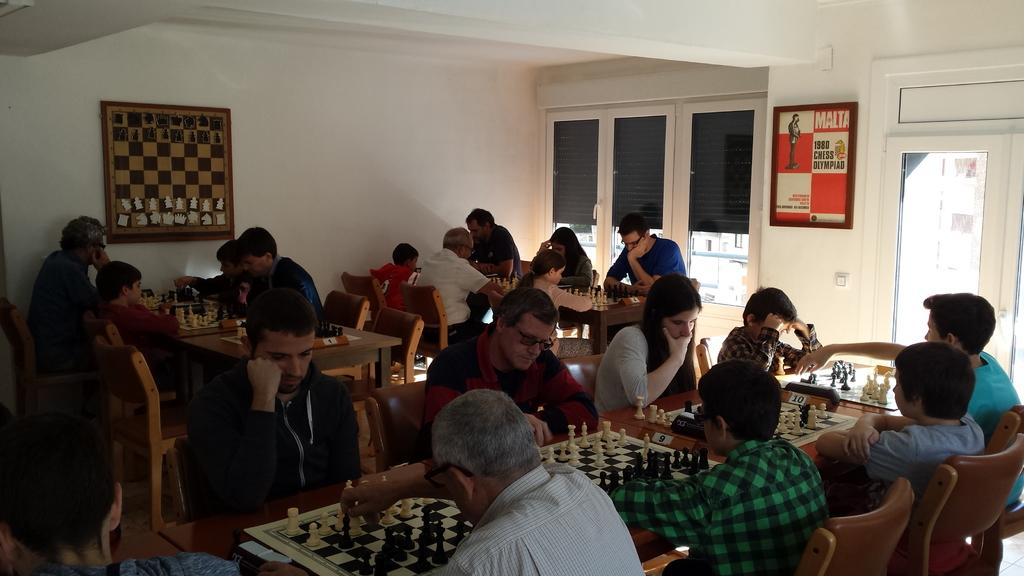What activity is taking place in the image? There is a chess competition in the image. How are the participants positioned during the competition? There are people sitting on chairs in the image. What game are the people playing? The people are playing chess. What type of prose can be heard being recited during the chess competition? There is no indication of any prose being recited during the chess competition in the image. 